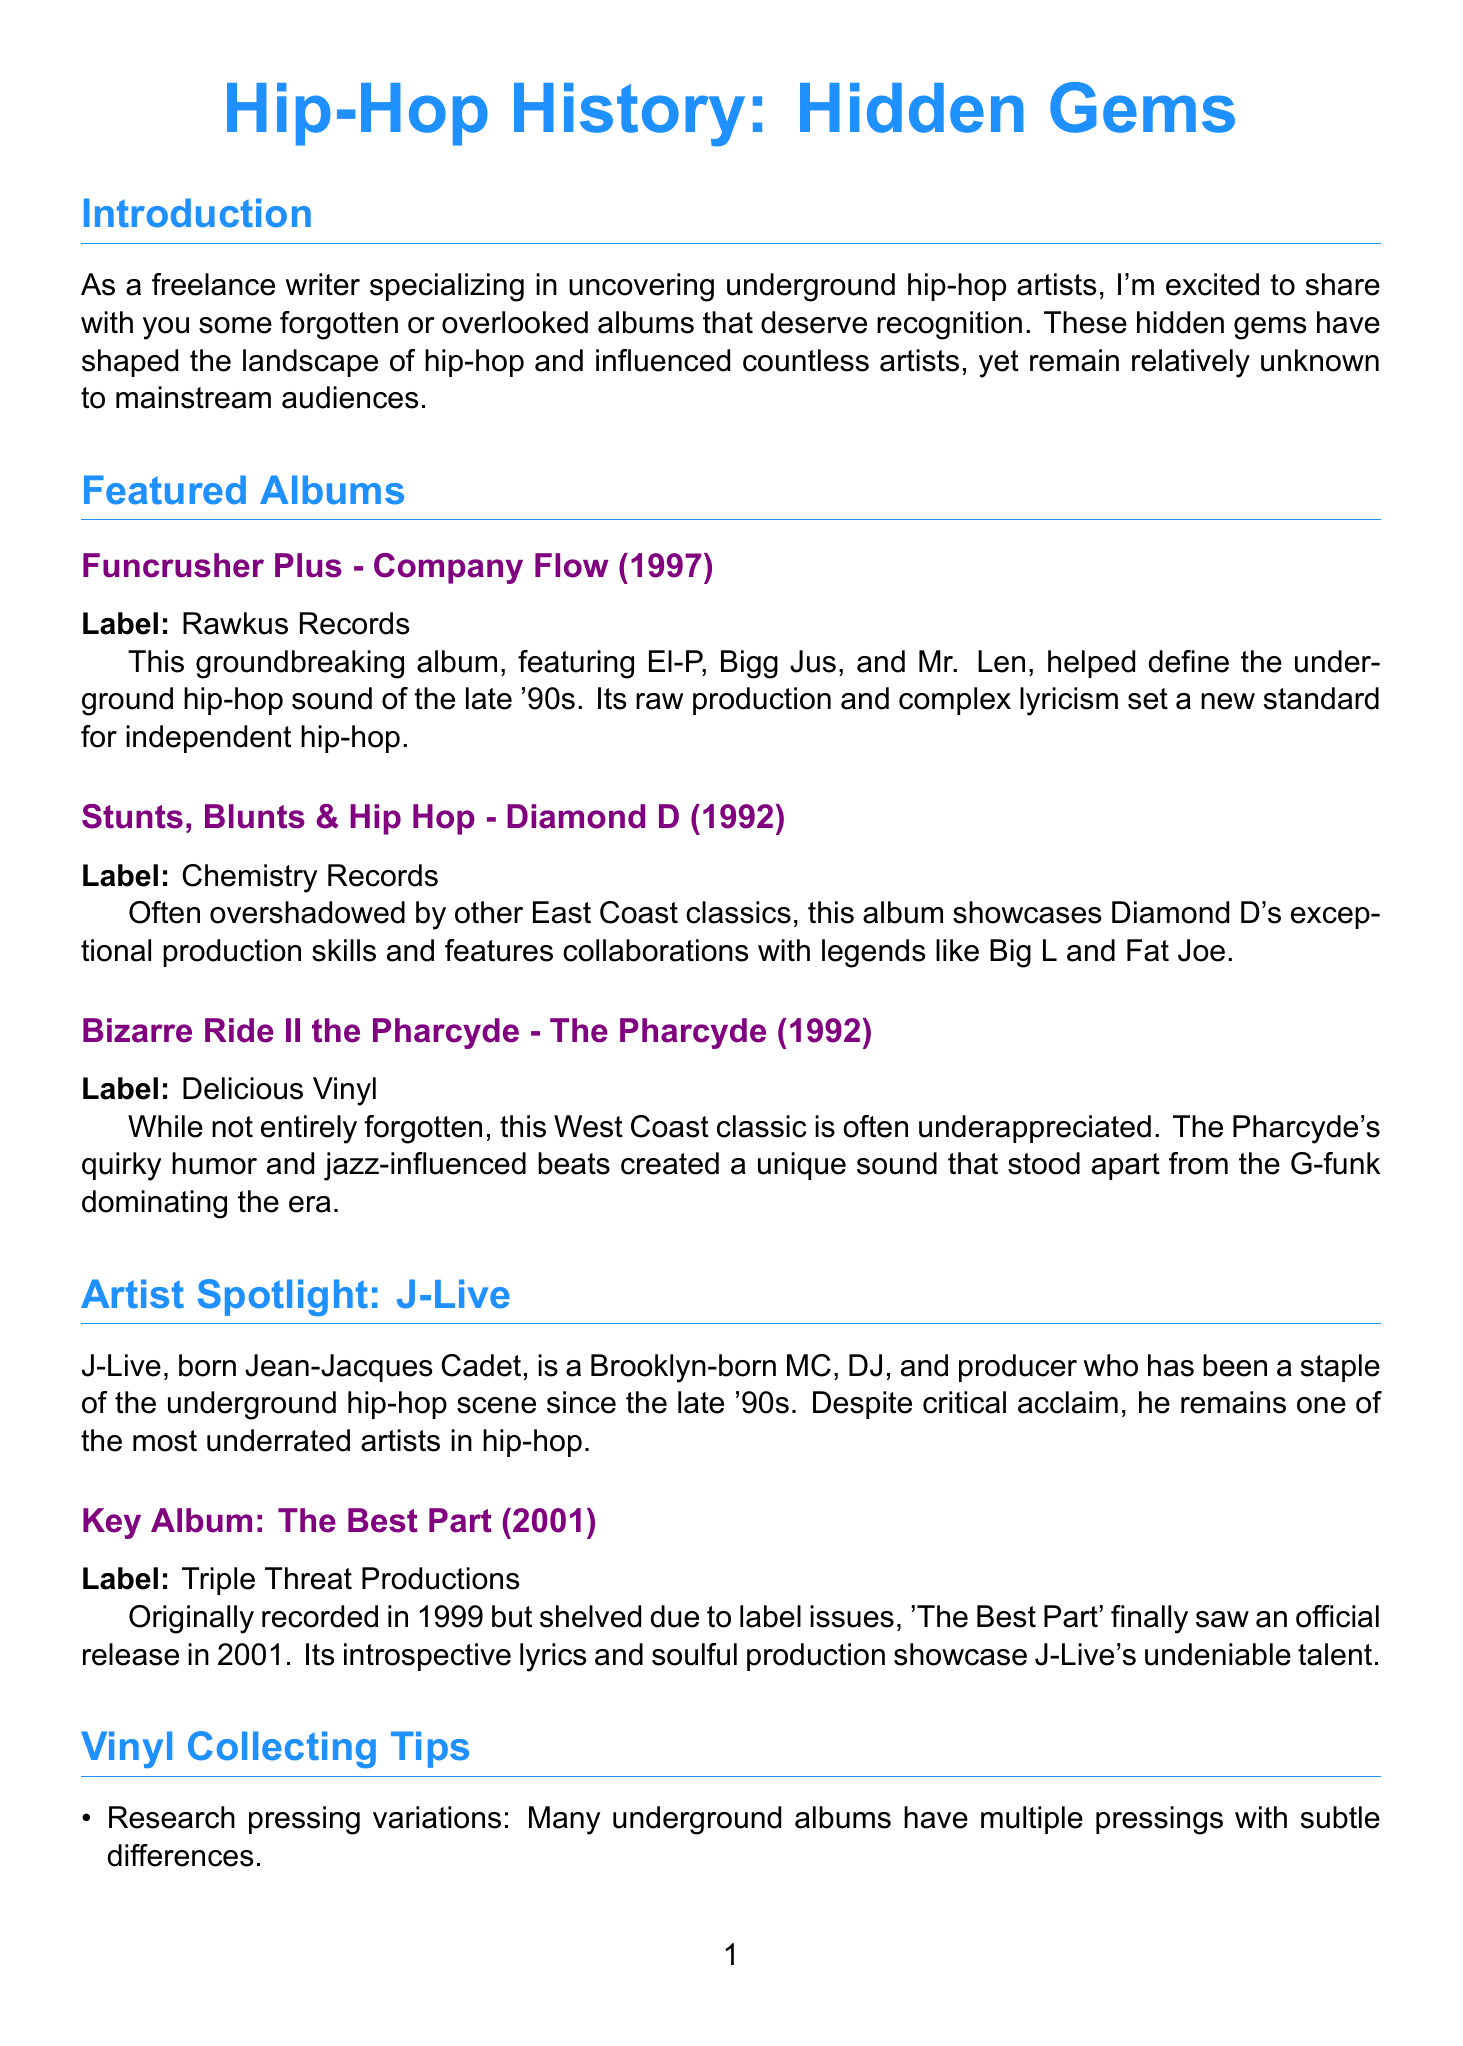What is the title of the newsletter? The title of the newsletter appears prominently at the top of the document.
Answer: Hip-Hop History: Hidden Gems Who is the featured artist in the spotlight section? The artist spotlight section highlights a specific underground artist within the newsletter.
Answer: J-Live What year was "Funcrusher Plus" released? The release year of "Funcrusher Plus" is stated in the featured album section of the document.
Answer: 1997 What label released "Stunts, Blunts & Hip Hop"? The label information for "Stunts, Blunts & Hip Hop" is provided next to the album’s title.
Answer: Chemistry Records What is one of the vinyl collecting tips listed? The document includes several tips on collecting vinyl records, indicating specific advice.
Answer: Research pressing variations In what year does the "Company Flow Reunion Show" take place? The date for the Company Flow Reunion Show is specified within the upcoming events section.
Answer: 2023 Which album was originally recorded in 1999? The key album under the artist spotlight has additional information about its original recording year.
Answer: The Best Part Which city is hosting the "Underground Hip-Hop Vinyl Swap"? The location for the upcoming event is mentioned in the event details.
Answer: New York City What album does J-Live’s key album represent? The document identifies a specific album under the artist's spotlight that showcases J-Live's work.
Answer: The Best Part 